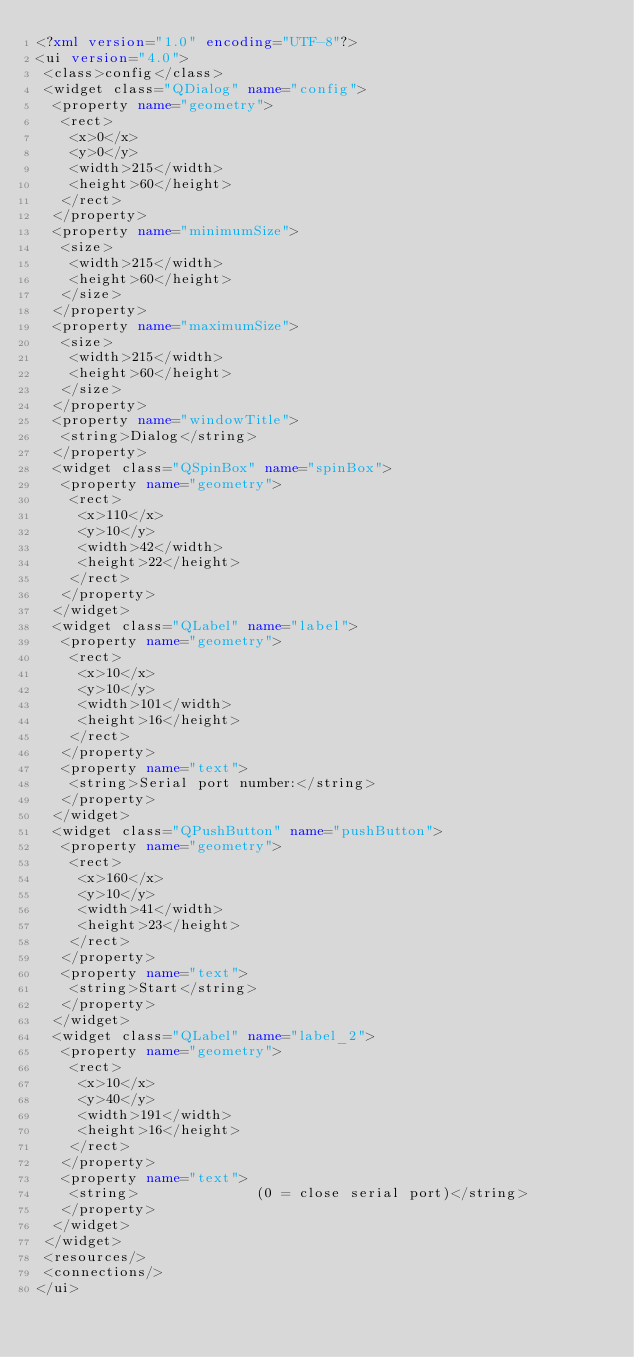Convert code to text. <code><loc_0><loc_0><loc_500><loc_500><_XML_><?xml version="1.0" encoding="UTF-8"?>
<ui version="4.0">
 <class>config</class>
 <widget class="QDialog" name="config">
  <property name="geometry">
   <rect>
    <x>0</x>
    <y>0</y>
    <width>215</width>
    <height>60</height>
   </rect>
  </property>
  <property name="minimumSize">
   <size>
    <width>215</width>
    <height>60</height>
   </size>
  </property>
  <property name="maximumSize">
   <size>
    <width>215</width>
    <height>60</height>
   </size>
  </property>
  <property name="windowTitle">
   <string>Dialog</string>
  </property>
  <widget class="QSpinBox" name="spinBox">
   <property name="geometry">
    <rect>
     <x>110</x>
     <y>10</y>
     <width>42</width>
     <height>22</height>
    </rect>
   </property>
  </widget>
  <widget class="QLabel" name="label">
   <property name="geometry">
    <rect>
     <x>10</x>
     <y>10</y>
     <width>101</width>
     <height>16</height>
    </rect>
   </property>
   <property name="text">
    <string>Serial port number:</string>
   </property>
  </widget>
  <widget class="QPushButton" name="pushButton">
   <property name="geometry">
    <rect>
     <x>160</x>
     <y>10</y>
     <width>41</width>
     <height>23</height>
    </rect>
   </property>
   <property name="text">
    <string>Start</string>
   </property>
  </widget>
  <widget class="QLabel" name="label_2">
   <property name="geometry">
    <rect>
     <x>10</x>
     <y>40</y>
     <width>191</width>
     <height>16</height>
    </rect>
   </property>
   <property name="text">
    <string>              (0 = close serial port)</string>
   </property>
  </widget>
 </widget>
 <resources/>
 <connections/>
</ui>
</code> 